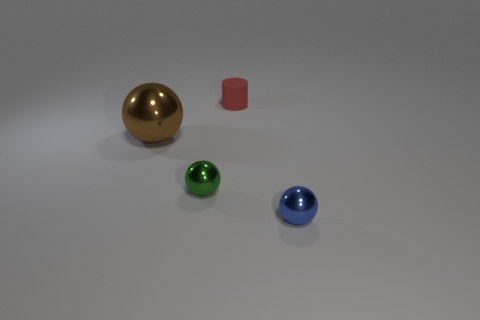The metal thing behind the tiny shiny object to the left of the metal ball to the right of the small red rubber cylinder is what shape?
Provide a short and direct response. Sphere. What is the thing that is both left of the small cylinder and in front of the brown metallic thing made of?
Give a very brief answer. Metal. Is the number of big brown metallic spheres less than the number of tiny purple cubes?
Your answer should be very brief. No. Do the big brown shiny thing and the metallic object that is in front of the green ball have the same shape?
Your response must be concise. Yes. There is a metallic object that is right of the matte thing; is it the same size as the tiny green thing?
Give a very brief answer. Yes. There is a green object that is the same size as the blue ball; what is its shape?
Your answer should be compact. Sphere. Do the big thing and the tiny rubber object have the same shape?
Offer a terse response. No. What number of other objects are the same shape as the small red thing?
Offer a very short reply. 0. How many large objects are to the right of the red matte cylinder?
Offer a very short reply. 0. There is a tiny sphere on the left side of the tiny red matte cylinder; is it the same color as the large shiny object?
Offer a very short reply. No. 